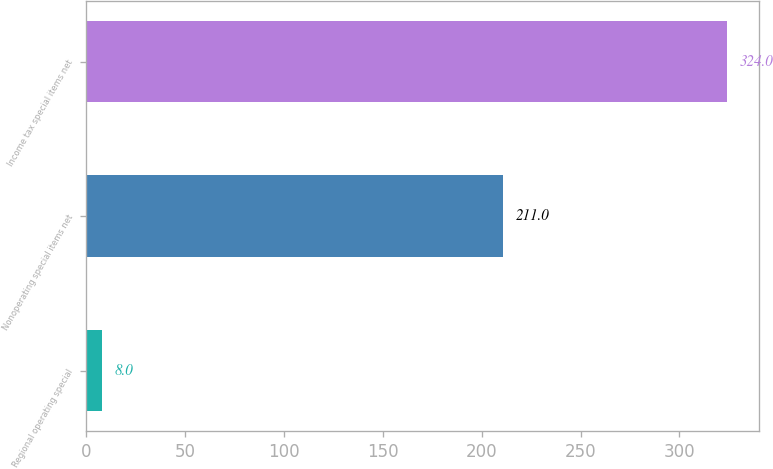Convert chart. <chart><loc_0><loc_0><loc_500><loc_500><bar_chart><fcel>Regional operating special<fcel>Nonoperating special items net<fcel>Income tax special items net<nl><fcel>8<fcel>211<fcel>324<nl></chart> 